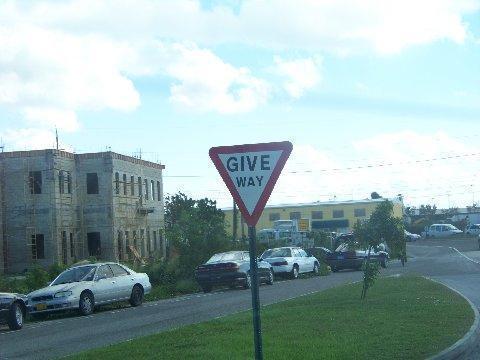How many street signs are in the picture?
Give a very brief answer. 1. How many cars are facing north in the picture?
Give a very brief answer. 4. 